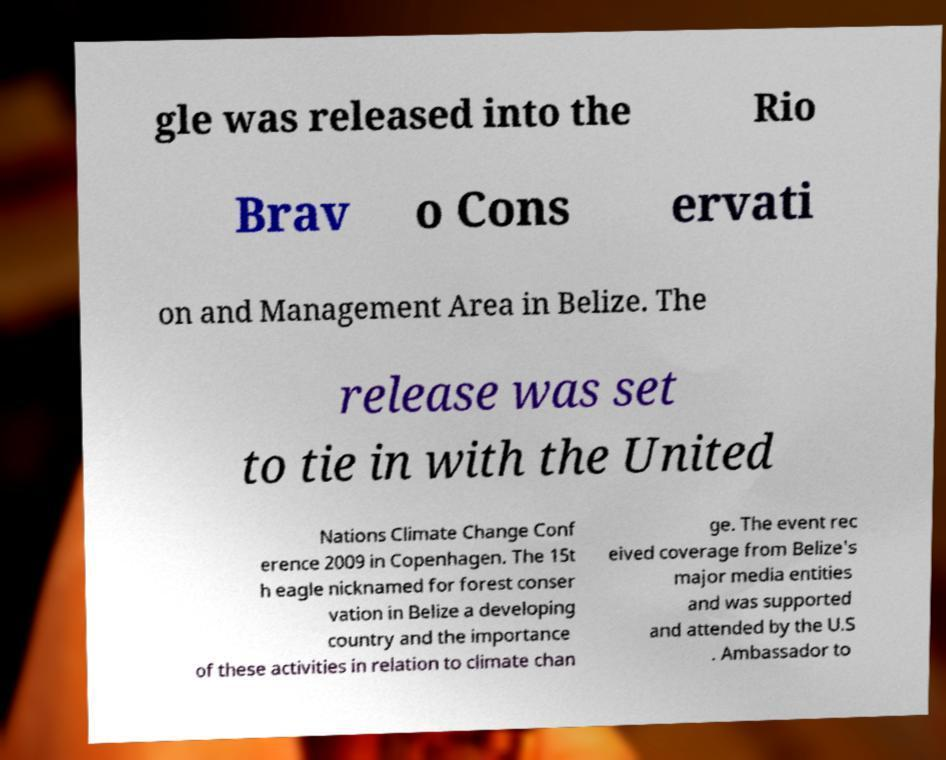Please read and relay the text visible in this image. What does it say? gle was released into the Rio Brav o Cons ervati on and Management Area in Belize. The release was set to tie in with the United Nations Climate Change Conf erence 2009 in Copenhagen. The 15t h eagle nicknamed for forest conser vation in Belize a developing country and the importance of these activities in relation to climate chan ge. The event rec eived coverage from Belize's major media entities and was supported and attended by the U.S . Ambassador to 